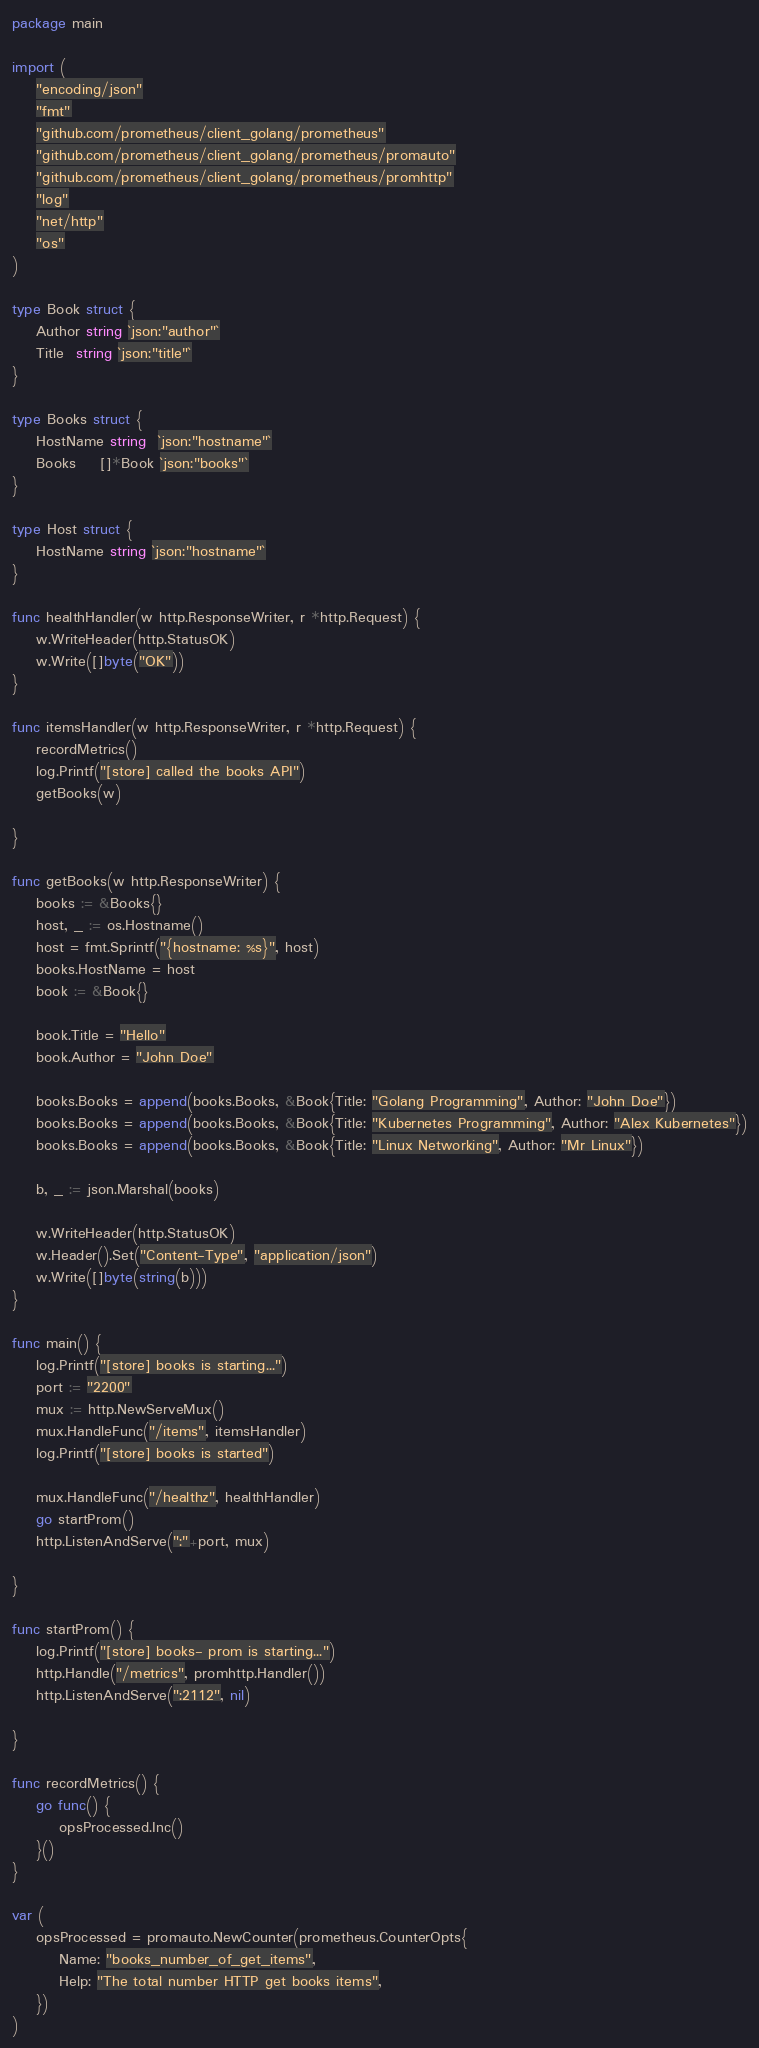<code> <loc_0><loc_0><loc_500><loc_500><_Go_>package main

import (
	"encoding/json"
	"fmt"
	"github.com/prometheus/client_golang/prometheus"
	"github.com/prometheus/client_golang/prometheus/promauto"
	"github.com/prometheus/client_golang/prometheus/promhttp"
	"log"
	"net/http"
	"os"
)

type Book struct {
	Author string `json:"author"`
	Title  string `json:"title"`
}

type Books struct {
	HostName string  `json:"hostname"`
	Books    []*Book `json:"books"`
}

type Host struct {
	HostName string `json:"hostname"`
}

func healthHandler(w http.ResponseWriter, r *http.Request) {
	w.WriteHeader(http.StatusOK)
	w.Write([]byte("OK"))
}

func itemsHandler(w http.ResponseWriter, r *http.Request) {
	recordMetrics()
	log.Printf("[store] called the books API")
	getBooks(w)

}

func getBooks(w http.ResponseWriter) {
	books := &Books{}
	host, _ := os.Hostname()
	host = fmt.Sprintf("{hostname: %s}", host)
	books.HostName = host
	book := &Book{}

	book.Title = "Hello"
	book.Author = "John Doe"

	books.Books = append(books.Books, &Book{Title: "Golang Programming", Author: "John Doe"})
	books.Books = append(books.Books, &Book{Title: "Kubernetes Programming", Author: "Alex Kubernetes"})
	books.Books = append(books.Books, &Book{Title: "Linux Networking", Author: "Mr Linux"})

	b, _ := json.Marshal(books)

	w.WriteHeader(http.StatusOK)
	w.Header().Set("Content-Type", "application/json")
	w.Write([]byte(string(b)))
}

func main() {
	log.Printf("[store] books is starting...")
	port := "2200"
	mux := http.NewServeMux()
	mux.HandleFunc("/items", itemsHandler)
	log.Printf("[store] books is started")

	mux.HandleFunc("/healthz", healthHandler)
	go startProm()
	http.ListenAndServe(":"+port, mux)

}

func startProm() {
	log.Printf("[store] books- prom is starting...")
	http.Handle("/metrics", promhttp.Handler())
	http.ListenAndServe(":2112", nil)

}

func recordMetrics() {
	go func() {
		opsProcessed.Inc()
	}()
}

var (
	opsProcessed = promauto.NewCounter(prometheus.CounterOpts{
		Name: "books_number_of_get_items",
		Help: "The total number HTTP get books items",
	})
)
</code> 